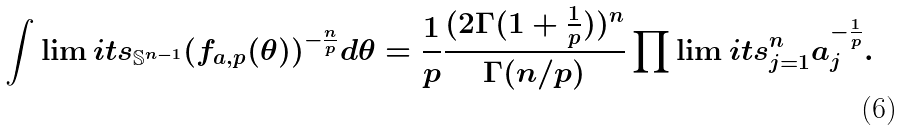<formula> <loc_0><loc_0><loc_500><loc_500>\int \lim i t s _ { \mathbb { S } ^ { n - 1 } } ( f _ { a , p } ( \theta ) ) ^ { - \frac { n } { p } } d \theta = \frac { 1 } { p } \frac { ( 2 \Gamma ( 1 + \frac { 1 } { p } ) ) ^ { n } } { \Gamma ( n / p ) } \prod \lim i t s _ { j = 1 } ^ { n } a _ { j } ^ { - \frac { 1 } { p } } .</formula> 